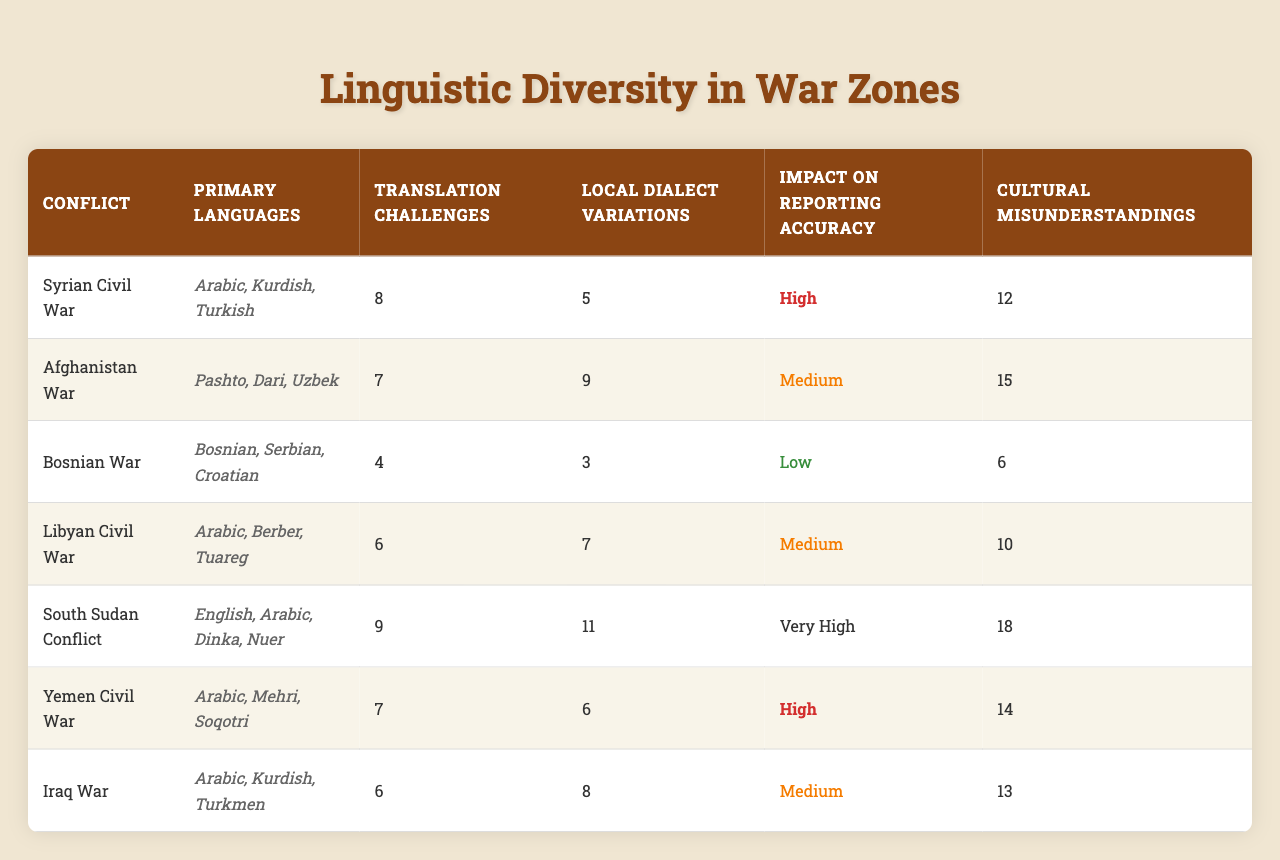What are the primary languages spoken in the Syrian Civil War? The table shows that the primary languages in the Syrian Civil War are Arabic, Kurdish, and Turkish.
Answer: Arabic, Kurdish, Turkish Which conflict has the highest number of cultural misunderstandings? By reviewing the table, the South Sudan Conflict has 18 cultural misunderstandings, which is the highest among all listed conflicts.
Answer: South Sudan Conflict How many local dialect variations are present in the Afghanistan War? The table indicates that there are 9 local dialect variations in the Afghanistan War.
Answer: 9 What is the average number of translation challenges across all conflicts? The total number of translation challenges is (8 + 7 + 4 + 6 + 9 + 7 + 6) = 47. There are 7 conflicts, so the average is 47/7 = 6.71.
Answer: 6.71 Which conflict has a very high impact on reporting accuracy? According to the table, the South Sudan Conflict has a very high impact on reporting accuracy.
Answer: South Sudan Conflict Is it true that the Bosnian War has more cultural misunderstandings than the Libyan Civil War? The table shows that the Bosnian War has 6 cultural misunderstandings while the Libyan Civil War has 10, therefore the statement is false.
Answer: False What is the difference in translation challenges between the South Sudan Conflict and the Iraqi War? The South Sudan Conflict has 9 translation challenges while the Iraqi War has 6. The difference is 9 - 6 = 3.
Answer: 3 Which conflict has the lowest impact on reporting accuracy? The table indicates that the Bosnian War has the lowest impact on reporting accuracy, categorized as low.
Answer: Bosnian War How many total local dialect variations are present in the conflicts listed? The total local dialect variations can be summed as (5 + 9 + 3 + 7 + 11 + 6 + 8) = 49.
Answer: 49 Is Arabic one of the primary languages in the Yemen Civil War? The table confirms that Arabic is listed as one of the primary languages in the Yemen Civil War.
Answer: Yes 